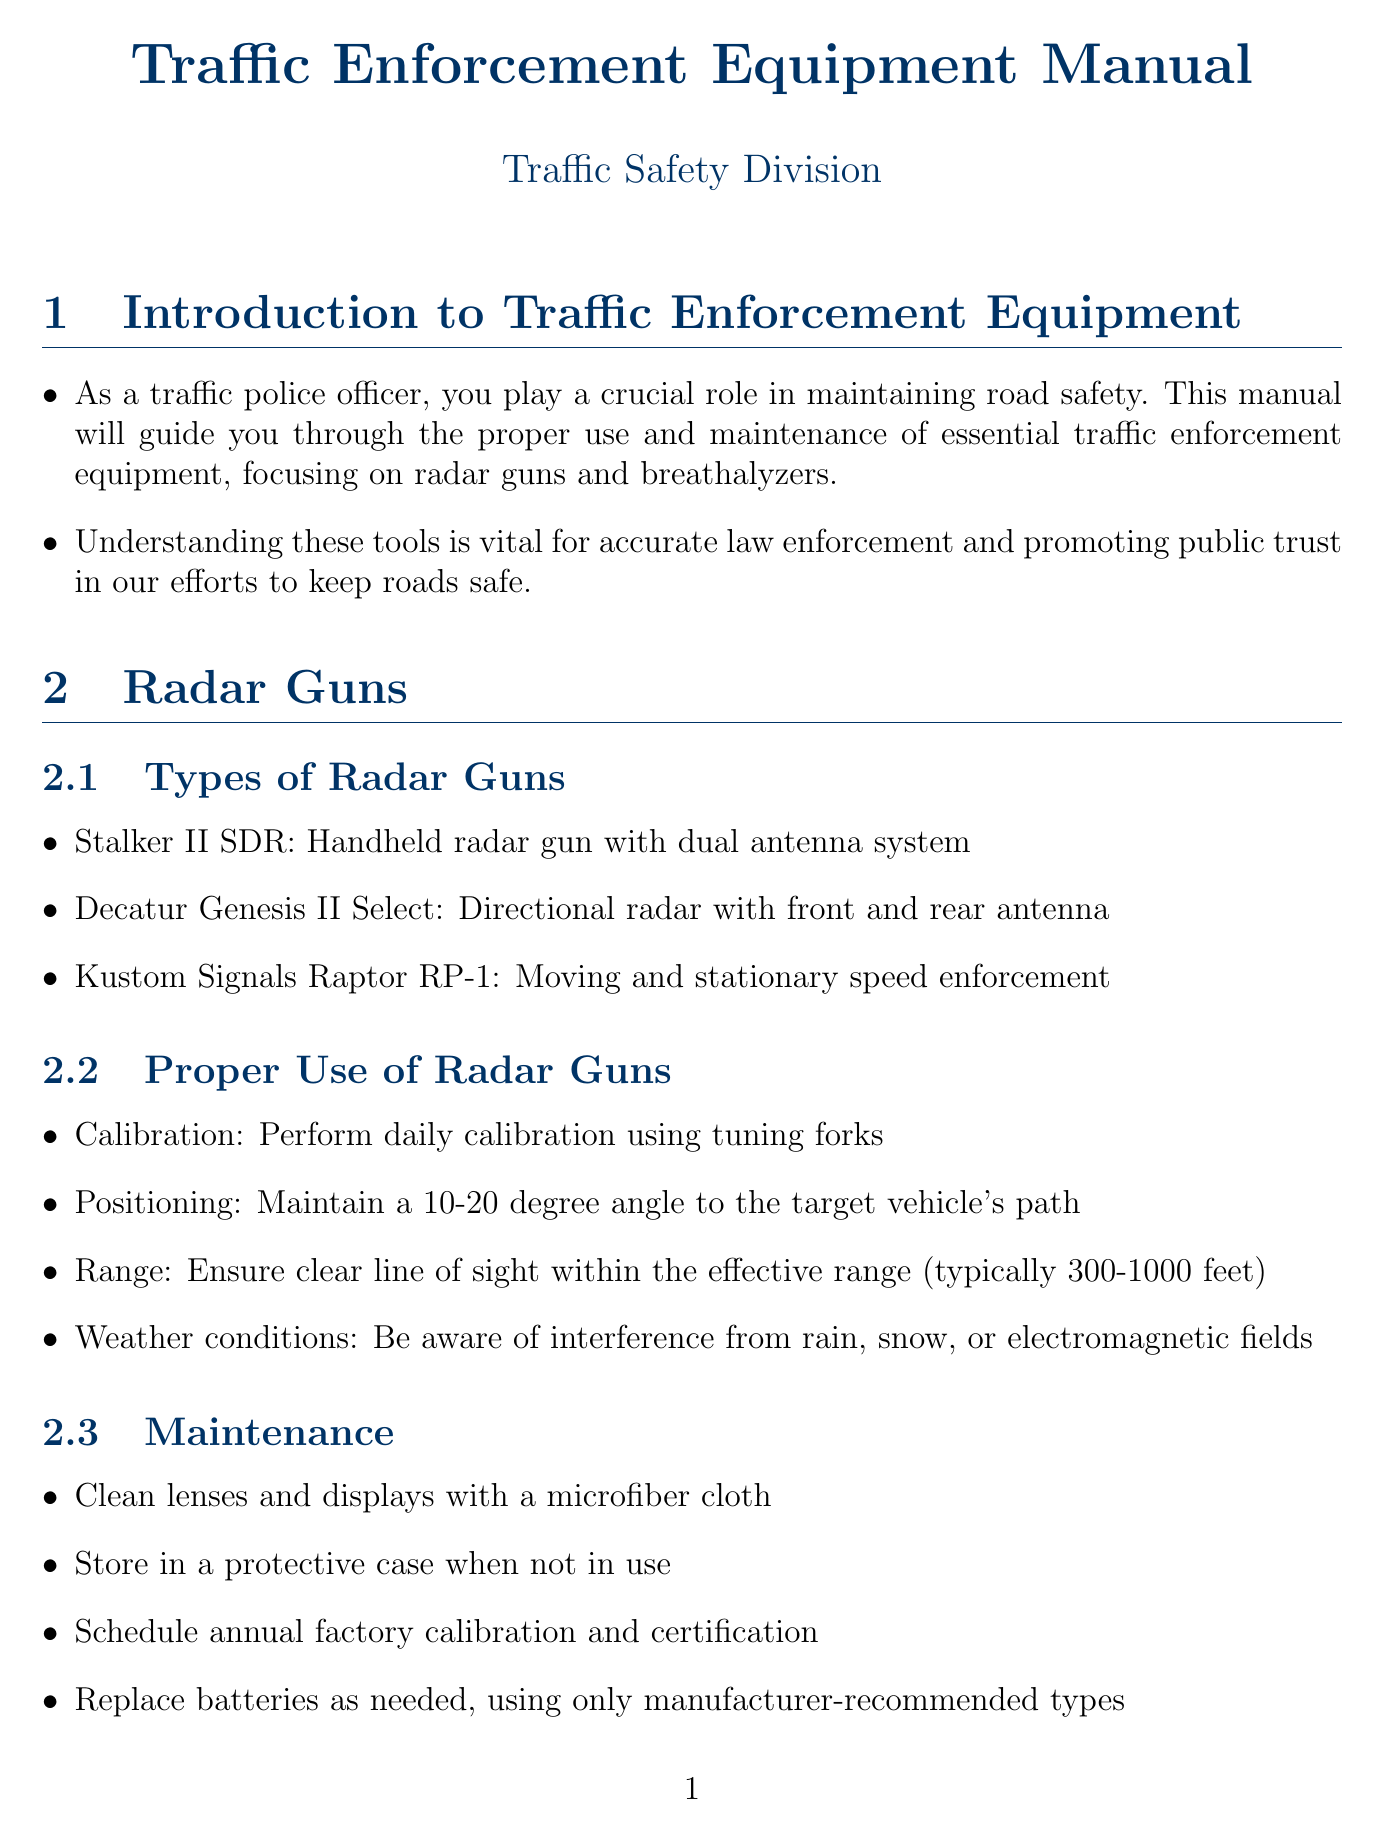What are the types of radar guns? The document lists three specific radar guns under the "Types of Radar Guns" subsection, which are examples of equipment used in traffic enforcement.
Answer: Stalker II SDR, Decatur Genesis II Select, Kustom Signals Raptor RP-1 What is the mandatory waiting period before using a breathalyzer? The document specifies a time requirement for breathalyzer use which is critical to ensure reliable results when testing for alcohol consumption.
Answer: 15 minutes What should be done if a radar gun is not powering on? The troubleshooting section provides steps to diagnose common issues with radar guns, highlighting the importance of regular checks.
Answer: Check battery connection and charge level What type of breathalyzer is the Intoxilyzer 8000? This question focuses on classifying a specific model mentioned in the document based on its function in traffic enforcement relating to alcohol testing.
Answer: Evidential breath alcohol testing device What is emphasized as the main goal of public relations for traffic enforcement? The document highlights the purpose of community interaction regarding traffic enforcement equipment, stressing a positive approach.
Answer: Road safety rather than punishment 